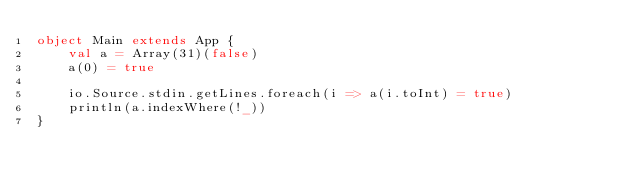Convert code to text. <code><loc_0><loc_0><loc_500><loc_500><_Scala_>object Main extends App {
    val a = Array(31)(false)
    a(0) = true

    io.Source.stdin.getLines.foreach(i => a(i.toInt) = true)
    println(a.indexWhere(!_))
}</code> 